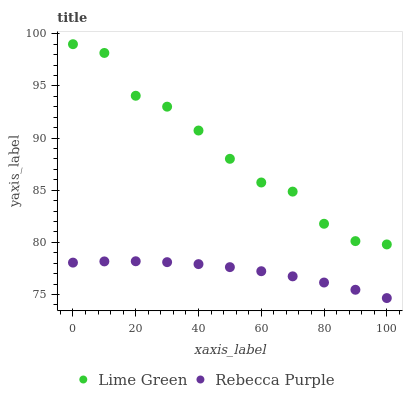Does Rebecca Purple have the minimum area under the curve?
Answer yes or no. Yes. Does Lime Green have the maximum area under the curve?
Answer yes or no. Yes. Does Rebecca Purple have the maximum area under the curve?
Answer yes or no. No. Is Rebecca Purple the smoothest?
Answer yes or no. Yes. Is Lime Green the roughest?
Answer yes or no. Yes. Is Rebecca Purple the roughest?
Answer yes or no. No. Does Rebecca Purple have the lowest value?
Answer yes or no. Yes. Does Lime Green have the highest value?
Answer yes or no. Yes. Does Rebecca Purple have the highest value?
Answer yes or no. No. Is Rebecca Purple less than Lime Green?
Answer yes or no. Yes. Is Lime Green greater than Rebecca Purple?
Answer yes or no. Yes. Does Rebecca Purple intersect Lime Green?
Answer yes or no. No. 